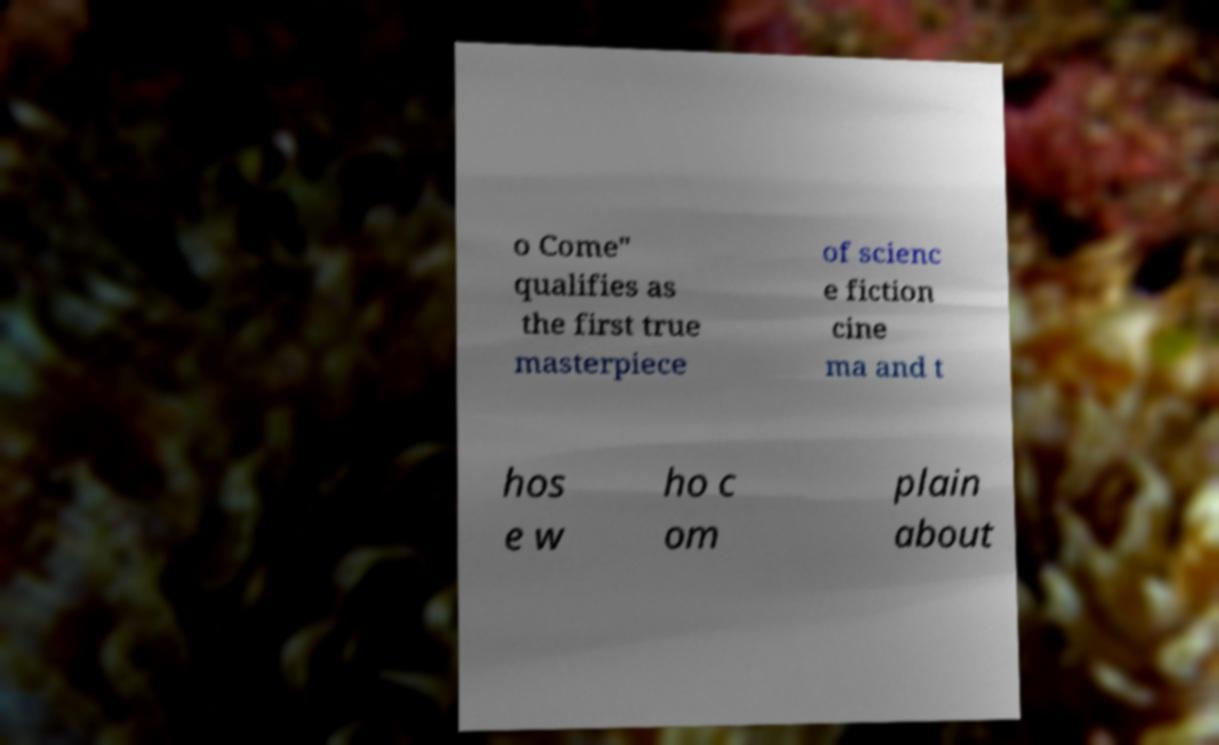Can you accurately transcribe the text from the provided image for me? o Come" qualifies as the first true masterpiece of scienc e fiction cine ma and t hos e w ho c om plain about 